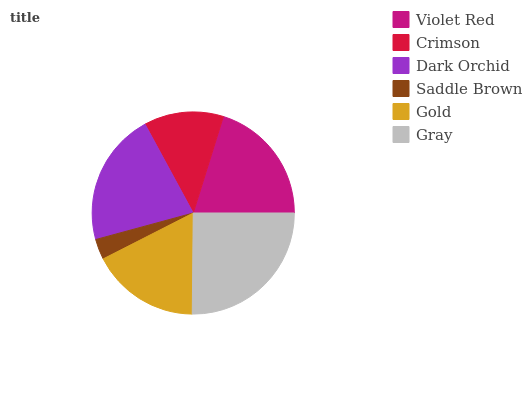Is Saddle Brown the minimum?
Answer yes or no. Yes. Is Gray the maximum?
Answer yes or no. Yes. Is Crimson the minimum?
Answer yes or no. No. Is Crimson the maximum?
Answer yes or no. No. Is Violet Red greater than Crimson?
Answer yes or no. Yes. Is Crimson less than Violet Red?
Answer yes or no. Yes. Is Crimson greater than Violet Red?
Answer yes or no. No. Is Violet Red less than Crimson?
Answer yes or no. No. Is Violet Red the high median?
Answer yes or no. Yes. Is Gold the low median?
Answer yes or no. Yes. Is Gold the high median?
Answer yes or no. No. Is Saddle Brown the low median?
Answer yes or no. No. 